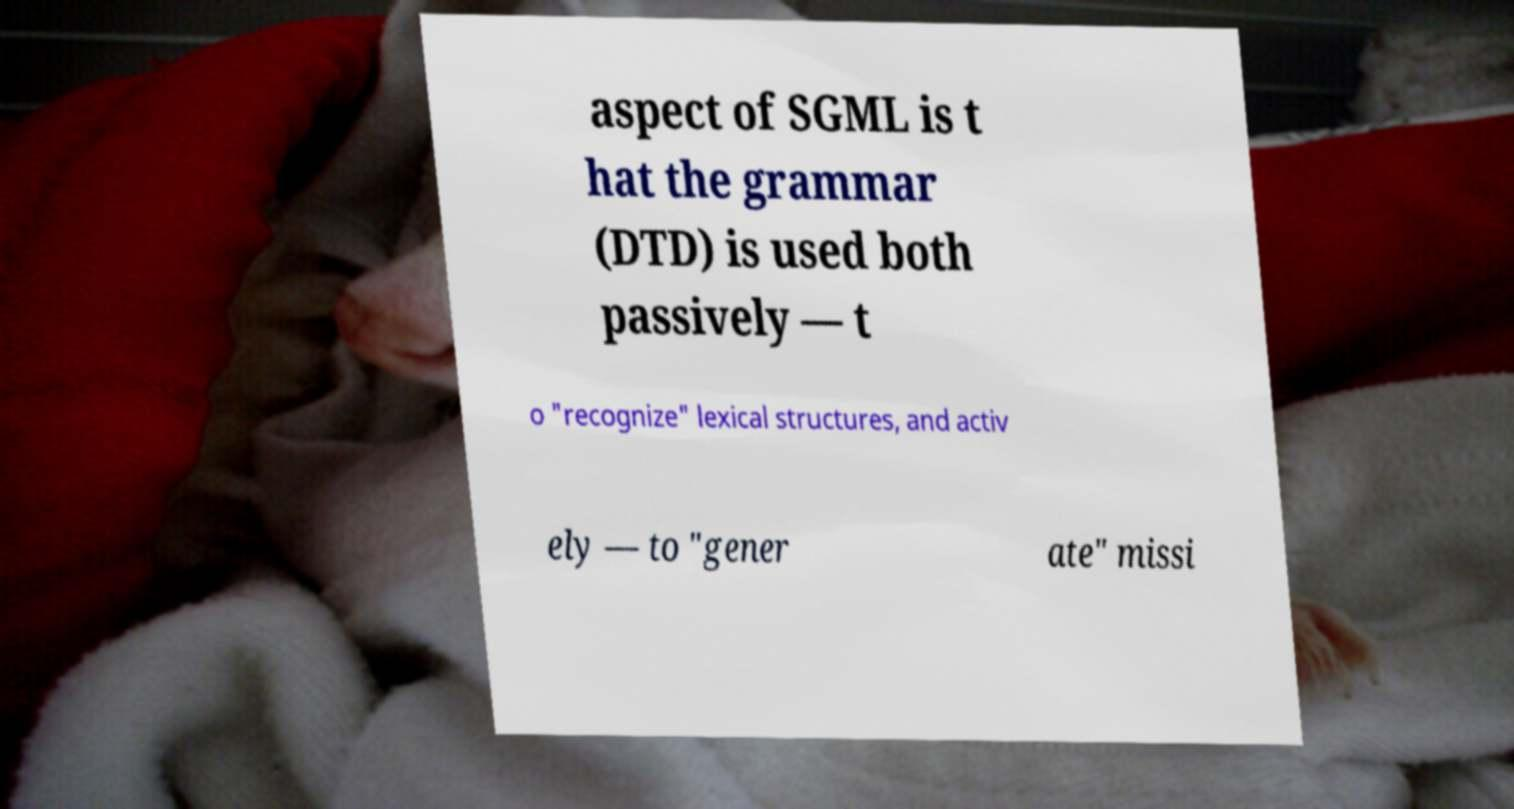Can you accurately transcribe the text from the provided image for me? aspect of SGML is t hat the grammar (DTD) is used both passively — t o "recognize" lexical structures, and activ ely — to "gener ate" missi 